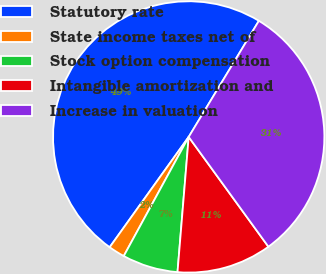<chart> <loc_0><loc_0><loc_500><loc_500><pie_chart><fcel>Statutory rate<fcel>State income taxes net of<fcel>Stock option compensation<fcel>Intangible amortization and<fcel>Increase in valuation<nl><fcel>48.76%<fcel>1.95%<fcel>6.63%<fcel>11.31%<fcel>31.35%<nl></chart> 